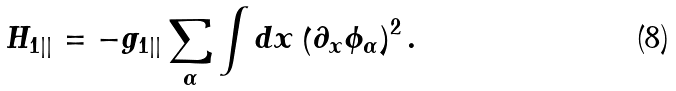Convert formula to latex. <formula><loc_0><loc_0><loc_500><loc_500>H _ { 1 | | } = - g _ { 1 | | } \sum _ { \alpha } \int d x \left ( \partial _ { x } \phi _ { \alpha } \right ) ^ { 2 } .</formula> 